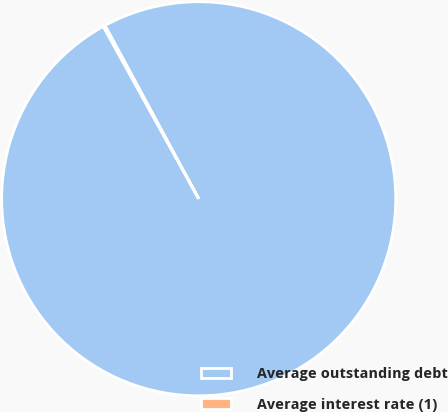<chart> <loc_0><loc_0><loc_500><loc_500><pie_chart><fcel>Average outstanding debt<fcel>Average interest rate (1)<nl><fcel>99.84%<fcel>0.16%<nl></chart> 